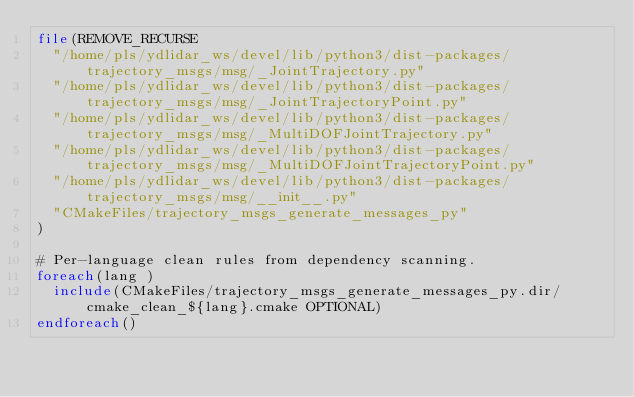Convert code to text. <code><loc_0><loc_0><loc_500><loc_500><_CMake_>file(REMOVE_RECURSE
  "/home/pls/ydlidar_ws/devel/lib/python3/dist-packages/trajectory_msgs/msg/_JointTrajectory.py"
  "/home/pls/ydlidar_ws/devel/lib/python3/dist-packages/trajectory_msgs/msg/_JointTrajectoryPoint.py"
  "/home/pls/ydlidar_ws/devel/lib/python3/dist-packages/trajectory_msgs/msg/_MultiDOFJointTrajectory.py"
  "/home/pls/ydlidar_ws/devel/lib/python3/dist-packages/trajectory_msgs/msg/_MultiDOFJointTrajectoryPoint.py"
  "/home/pls/ydlidar_ws/devel/lib/python3/dist-packages/trajectory_msgs/msg/__init__.py"
  "CMakeFiles/trajectory_msgs_generate_messages_py"
)

# Per-language clean rules from dependency scanning.
foreach(lang )
  include(CMakeFiles/trajectory_msgs_generate_messages_py.dir/cmake_clean_${lang}.cmake OPTIONAL)
endforeach()
</code> 